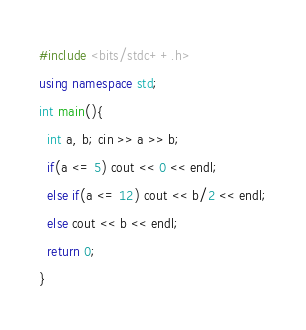Convert code to text. <code><loc_0><loc_0><loc_500><loc_500><_C++_>#include <bits/stdc++.h>
using namespace std;
int main(){
  int a, b; cin >> a >> b;
  if(a <= 5) cout << 0 << endl;
  else if(a <= 12) cout << b/2 << endl;
  else cout << b << endl;
  return 0;
}</code> 